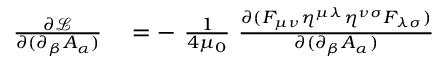<formula> <loc_0><loc_0><loc_500><loc_500>\begin{array} { r l } { { \frac { \partial { \mathcal { L } } } { \partial ( \partial _ { \beta } A _ { \alpha } ) } } } & = - \ { \frac { 1 } { 4 \mu _ { 0 } } } \ { \frac { \partial ( F _ { \mu \nu } \eta ^ { \mu \lambda } \eta ^ { \nu \sigma } F _ { \lambda \sigma } ) } { \partial ( \partial _ { \beta } A _ { \alpha } ) } } } \end{array}</formula> 